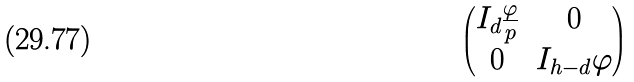<formula> <loc_0><loc_0><loc_500><loc_500>\begin{pmatrix} I _ { d } \frac { \varphi } { p } & 0 \\ 0 & I _ { h - d } \varphi \end{pmatrix}</formula> 